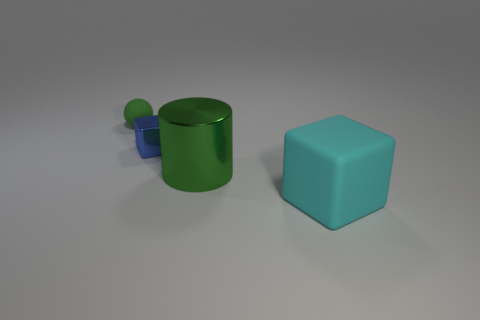What number of other objects are the same color as the small sphere?
Give a very brief answer. 1. There is a rubber thing on the left side of the cyan rubber cube; is its size the same as the cyan matte cube?
Your answer should be compact. No. What is the object that is behind the tiny blue shiny thing made of?
Your answer should be very brief. Rubber. Are there any other things that have the same shape as the large green object?
Make the answer very short. No. What number of rubber things are blue cubes or large green things?
Provide a succinct answer. 0. Are there fewer large metallic things that are in front of the cylinder than green things?
Give a very brief answer. Yes. What shape is the green thing in front of the small thing in front of the rubber thing that is behind the small blue metal block?
Give a very brief answer. Cylinder. Is the color of the tiny matte ball the same as the big metallic thing?
Your response must be concise. Yes. Are there more small green objects than small red shiny things?
Your answer should be very brief. Yes. How many other things are made of the same material as the big green object?
Make the answer very short. 1. 